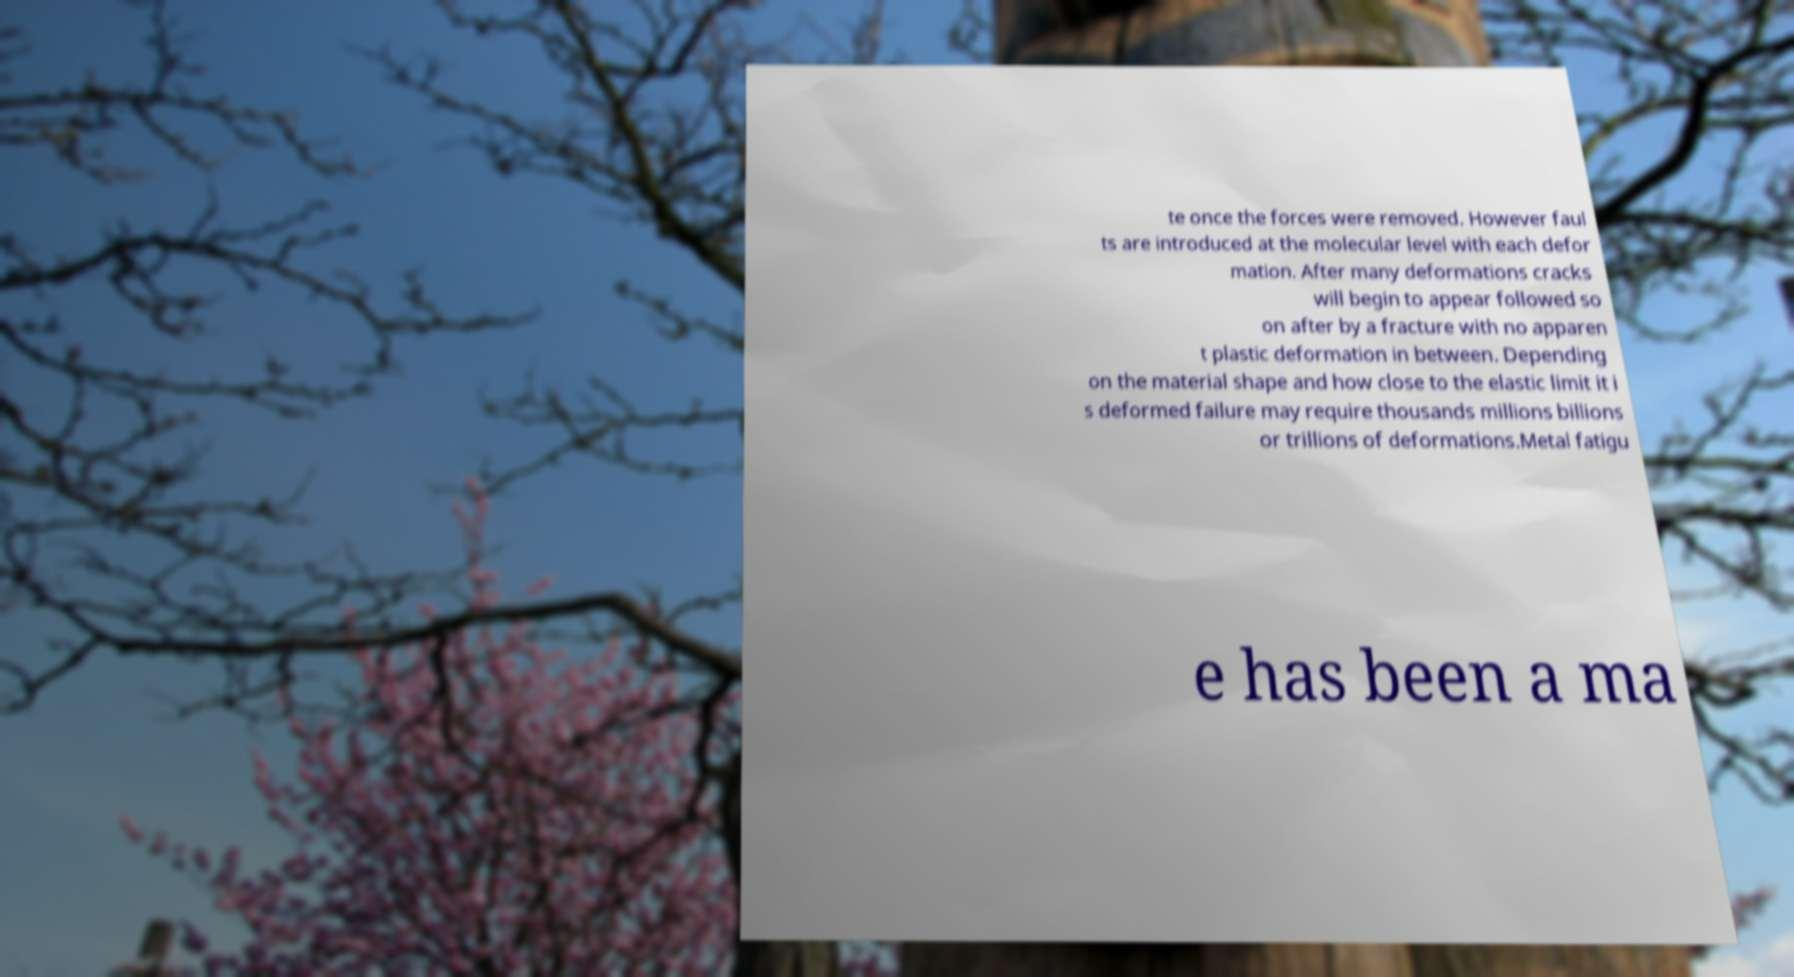What messages or text are displayed in this image? I need them in a readable, typed format. te once the forces were removed. However faul ts are introduced at the molecular level with each defor mation. After many deformations cracks will begin to appear followed so on after by a fracture with no apparen t plastic deformation in between. Depending on the material shape and how close to the elastic limit it i s deformed failure may require thousands millions billions or trillions of deformations.Metal fatigu e has been a ma 